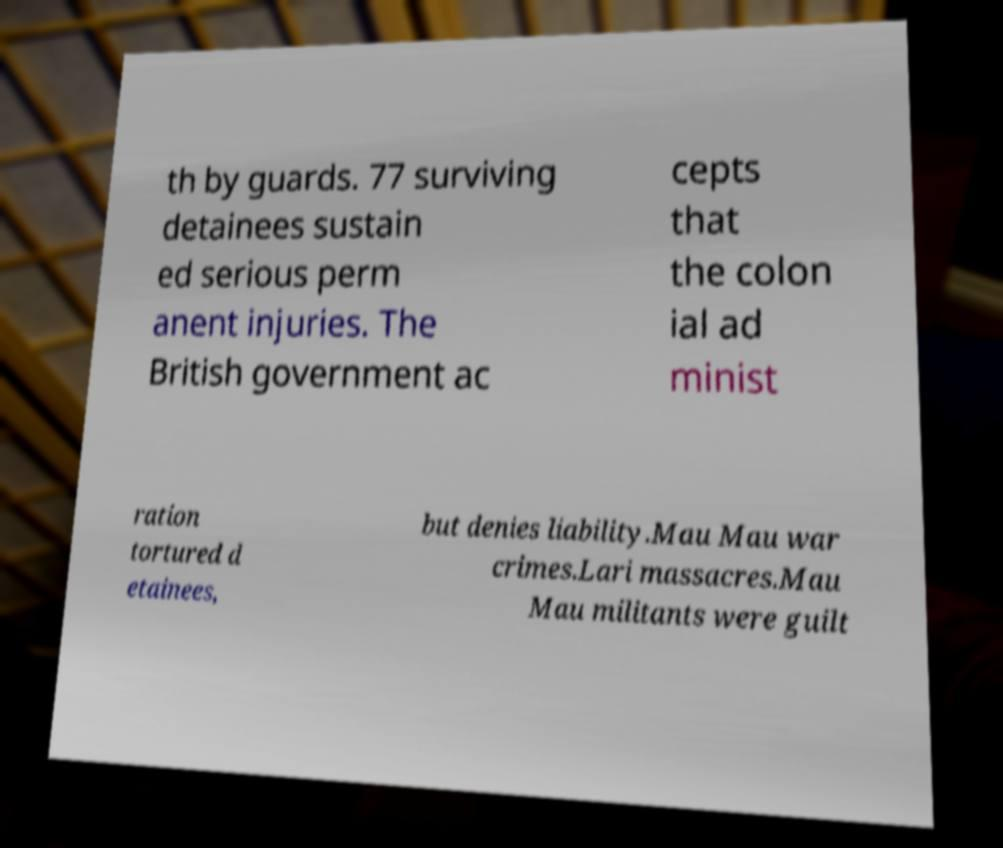Can you accurately transcribe the text from the provided image for me? th by guards. 77 surviving detainees sustain ed serious perm anent injuries. The British government ac cepts that the colon ial ad minist ration tortured d etainees, but denies liability.Mau Mau war crimes.Lari massacres.Mau Mau militants were guilt 